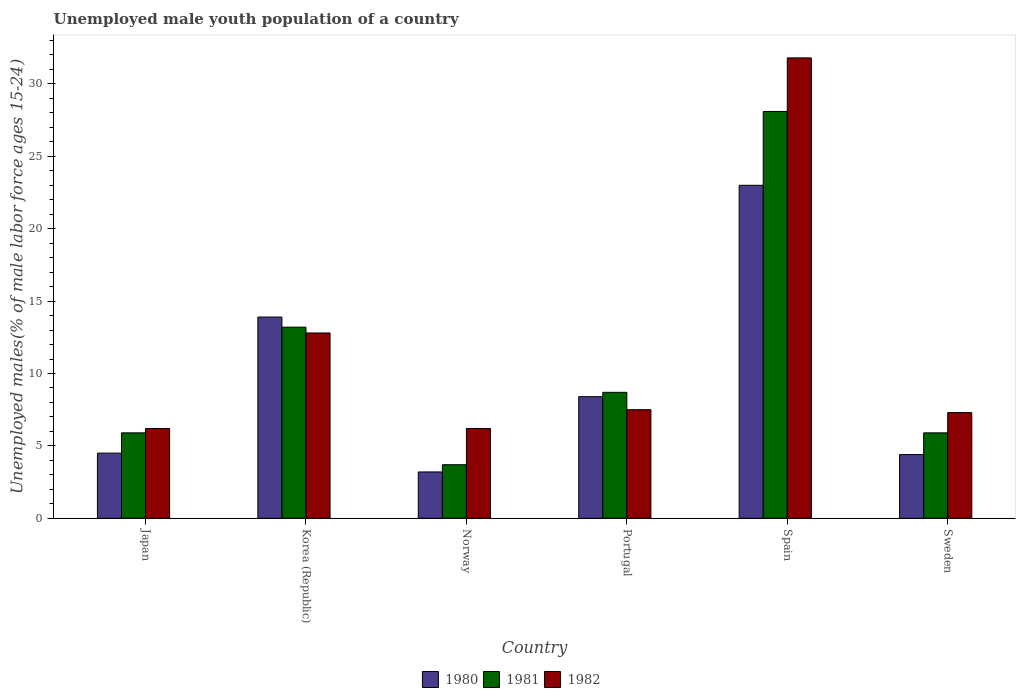How many different coloured bars are there?
Provide a short and direct response. 3. Are the number of bars per tick equal to the number of legend labels?
Offer a terse response. Yes. How many bars are there on the 4th tick from the left?
Your answer should be very brief. 3. What is the percentage of unemployed male youth population in 1981 in Portugal?
Keep it short and to the point. 8.7. Across all countries, what is the maximum percentage of unemployed male youth population in 1982?
Provide a short and direct response. 31.8. Across all countries, what is the minimum percentage of unemployed male youth population in 1980?
Your answer should be compact. 3.2. What is the total percentage of unemployed male youth population in 1981 in the graph?
Make the answer very short. 65.5. What is the difference between the percentage of unemployed male youth population in 1982 in Norway and that in Spain?
Give a very brief answer. -25.6. What is the difference between the percentage of unemployed male youth population in 1980 in Sweden and the percentage of unemployed male youth population in 1982 in Portugal?
Your answer should be compact. -3.1. What is the average percentage of unemployed male youth population in 1981 per country?
Provide a short and direct response. 10.92. What is the difference between the percentage of unemployed male youth population of/in 1981 and percentage of unemployed male youth population of/in 1980 in Sweden?
Make the answer very short. 1.5. In how many countries, is the percentage of unemployed male youth population in 1980 greater than 14 %?
Your response must be concise. 1. What is the ratio of the percentage of unemployed male youth population in 1980 in Japan to that in Korea (Republic)?
Your response must be concise. 0.32. Is the percentage of unemployed male youth population in 1981 in Norway less than that in Sweden?
Provide a short and direct response. Yes. What is the difference between the highest and the second highest percentage of unemployed male youth population in 1982?
Offer a terse response. 5.3. What is the difference between the highest and the lowest percentage of unemployed male youth population in 1982?
Provide a short and direct response. 25.6. Is the sum of the percentage of unemployed male youth population in 1982 in Japan and Spain greater than the maximum percentage of unemployed male youth population in 1980 across all countries?
Keep it short and to the point. Yes. What does the 2nd bar from the right in Portugal represents?
Provide a short and direct response. 1981. How many bars are there?
Give a very brief answer. 18. Are the values on the major ticks of Y-axis written in scientific E-notation?
Give a very brief answer. No. Does the graph contain any zero values?
Ensure brevity in your answer.  No. What is the title of the graph?
Provide a succinct answer. Unemployed male youth population of a country. Does "1960" appear as one of the legend labels in the graph?
Provide a short and direct response. No. What is the label or title of the Y-axis?
Keep it short and to the point. Unemployed males(% of male labor force ages 15-24). What is the Unemployed males(% of male labor force ages 15-24) of 1981 in Japan?
Your response must be concise. 5.9. What is the Unemployed males(% of male labor force ages 15-24) of 1982 in Japan?
Ensure brevity in your answer.  6.2. What is the Unemployed males(% of male labor force ages 15-24) of 1980 in Korea (Republic)?
Make the answer very short. 13.9. What is the Unemployed males(% of male labor force ages 15-24) of 1981 in Korea (Republic)?
Your answer should be very brief. 13.2. What is the Unemployed males(% of male labor force ages 15-24) of 1982 in Korea (Republic)?
Provide a short and direct response. 12.8. What is the Unemployed males(% of male labor force ages 15-24) of 1980 in Norway?
Provide a succinct answer. 3.2. What is the Unemployed males(% of male labor force ages 15-24) in 1981 in Norway?
Provide a short and direct response. 3.7. What is the Unemployed males(% of male labor force ages 15-24) in 1982 in Norway?
Offer a terse response. 6.2. What is the Unemployed males(% of male labor force ages 15-24) in 1980 in Portugal?
Provide a short and direct response. 8.4. What is the Unemployed males(% of male labor force ages 15-24) in 1981 in Portugal?
Your answer should be very brief. 8.7. What is the Unemployed males(% of male labor force ages 15-24) in 1982 in Portugal?
Your response must be concise. 7.5. What is the Unemployed males(% of male labor force ages 15-24) in 1980 in Spain?
Make the answer very short. 23. What is the Unemployed males(% of male labor force ages 15-24) in 1981 in Spain?
Your response must be concise. 28.1. What is the Unemployed males(% of male labor force ages 15-24) in 1982 in Spain?
Make the answer very short. 31.8. What is the Unemployed males(% of male labor force ages 15-24) in 1980 in Sweden?
Provide a succinct answer. 4.4. What is the Unemployed males(% of male labor force ages 15-24) of 1981 in Sweden?
Offer a very short reply. 5.9. What is the Unemployed males(% of male labor force ages 15-24) in 1982 in Sweden?
Ensure brevity in your answer.  7.3. Across all countries, what is the maximum Unemployed males(% of male labor force ages 15-24) in 1981?
Offer a terse response. 28.1. Across all countries, what is the maximum Unemployed males(% of male labor force ages 15-24) in 1982?
Make the answer very short. 31.8. Across all countries, what is the minimum Unemployed males(% of male labor force ages 15-24) of 1980?
Offer a terse response. 3.2. Across all countries, what is the minimum Unemployed males(% of male labor force ages 15-24) in 1981?
Make the answer very short. 3.7. Across all countries, what is the minimum Unemployed males(% of male labor force ages 15-24) in 1982?
Your response must be concise. 6.2. What is the total Unemployed males(% of male labor force ages 15-24) of 1980 in the graph?
Offer a very short reply. 57.4. What is the total Unemployed males(% of male labor force ages 15-24) of 1981 in the graph?
Keep it short and to the point. 65.5. What is the total Unemployed males(% of male labor force ages 15-24) in 1982 in the graph?
Your answer should be compact. 71.8. What is the difference between the Unemployed males(% of male labor force ages 15-24) of 1980 in Japan and that in Norway?
Your answer should be compact. 1.3. What is the difference between the Unemployed males(% of male labor force ages 15-24) of 1982 in Japan and that in Norway?
Ensure brevity in your answer.  0. What is the difference between the Unemployed males(% of male labor force ages 15-24) in 1980 in Japan and that in Portugal?
Ensure brevity in your answer.  -3.9. What is the difference between the Unemployed males(% of male labor force ages 15-24) in 1982 in Japan and that in Portugal?
Your response must be concise. -1.3. What is the difference between the Unemployed males(% of male labor force ages 15-24) in 1980 in Japan and that in Spain?
Make the answer very short. -18.5. What is the difference between the Unemployed males(% of male labor force ages 15-24) in 1981 in Japan and that in Spain?
Provide a succinct answer. -22.2. What is the difference between the Unemployed males(% of male labor force ages 15-24) in 1982 in Japan and that in Spain?
Offer a very short reply. -25.6. What is the difference between the Unemployed males(% of male labor force ages 15-24) of 1981 in Japan and that in Sweden?
Give a very brief answer. 0. What is the difference between the Unemployed males(% of male labor force ages 15-24) of 1982 in Japan and that in Sweden?
Your response must be concise. -1.1. What is the difference between the Unemployed males(% of male labor force ages 15-24) in 1981 in Korea (Republic) and that in Norway?
Offer a very short reply. 9.5. What is the difference between the Unemployed males(% of male labor force ages 15-24) in 1982 in Korea (Republic) and that in Norway?
Your answer should be very brief. 6.6. What is the difference between the Unemployed males(% of male labor force ages 15-24) of 1980 in Korea (Republic) and that in Portugal?
Provide a short and direct response. 5.5. What is the difference between the Unemployed males(% of male labor force ages 15-24) of 1982 in Korea (Republic) and that in Portugal?
Keep it short and to the point. 5.3. What is the difference between the Unemployed males(% of male labor force ages 15-24) in 1980 in Korea (Republic) and that in Spain?
Provide a short and direct response. -9.1. What is the difference between the Unemployed males(% of male labor force ages 15-24) in 1981 in Korea (Republic) and that in Spain?
Provide a short and direct response. -14.9. What is the difference between the Unemployed males(% of male labor force ages 15-24) in 1982 in Korea (Republic) and that in Spain?
Offer a terse response. -19. What is the difference between the Unemployed males(% of male labor force ages 15-24) in 1981 in Korea (Republic) and that in Sweden?
Give a very brief answer. 7.3. What is the difference between the Unemployed males(% of male labor force ages 15-24) of 1980 in Norway and that in Portugal?
Give a very brief answer. -5.2. What is the difference between the Unemployed males(% of male labor force ages 15-24) of 1982 in Norway and that in Portugal?
Provide a short and direct response. -1.3. What is the difference between the Unemployed males(% of male labor force ages 15-24) of 1980 in Norway and that in Spain?
Ensure brevity in your answer.  -19.8. What is the difference between the Unemployed males(% of male labor force ages 15-24) in 1981 in Norway and that in Spain?
Provide a succinct answer. -24.4. What is the difference between the Unemployed males(% of male labor force ages 15-24) of 1982 in Norway and that in Spain?
Your response must be concise. -25.6. What is the difference between the Unemployed males(% of male labor force ages 15-24) in 1980 in Norway and that in Sweden?
Keep it short and to the point. -1.2. What is the difference between the Unemployed males(% of male labor force ages 15-24) of 1982 in Norway and that in Sweden?
Ensure brevity in your answer.  -1.1. What is the difference between the Unemployed males(% of male labor force ages 15-24) in 1980 in Portugal and that in Spain?
Your answer should be very brief. -14.6. What is the difference between the Unemployed males(% of male labor force ages 15-24) of 1981 in Portugal and that in Spain?
Make the answer very short. -19.4. What is the difference between the Unemployed males(% of male labor force ages 15-24) of 1982 in Portugal and that in Spain?
Your answer should be very brief. -24.3. What is the difference between the Unemployed males(% of male labor force ages 15-24) of 1981 in Portugal and that in Sweden?
Your response must be concise. 2.8. What is the difference between the Unemployed males(% of male labor force ages 15-24) of 1982 in Portugal and that in Sweden?
Ensure brevity in your answer.  0.2. What is the difference between the Unemployed males(% of male labor force ages 15-24) of 1981 in Spain and that in Sweden?
Your answer should be very brief. 22.2. What is the difference between the Unemployed males(% of male labor force ages 15-24) of 1980 in Japan and the Unemployed males(% of male labor force ages 15-24) of 1981 in Korea (Republic)?
Provide a succinct answer. -8.7. What is the difference between the Unemployed males(% of male labor force ages 15-24) in 1980 in Japan and the Unemployed males(% of male labor force ages 15-24) in 1982 in Korea (Republic)?
Provide a succinct answer. -8.3. What is the difference between the Unemployed males(% of male labor force ages 15-24) of 1981 in Japan and the Unemployed males(% of male labor force ages 15-24) of 1982 in Korea (Republic)?
Make the answer very short. -6.9. What is the difference between the Unemployed males(% of male labor force ages 15-24) in 1980 in Japan and the Unemployed males(% of male labor force ages 15-24) in 1982 in Norway?
Your answer should be compact. -1.7. What is the difference between the Unemployed males(% of male labor force ages 15-24) of 1980 in Japan and the Unemployed males(% of male labor force ages 15-24) of 1981 in Portugal?
Offer a terse response. -4.2. What is the difference between the Unemployed males(% of male labor force ages 15-24) in 1980 in Japan and the Unemployed males(% of male labor force ages 15-24) in 1982 in Portugal?
Offer a terse response. -3. What is the difference between the Unemployed males(% of male labor force ages 15-24) of 1980 in Japan and the Unemployed males(% of male labor force ages 15-24) of 1981 in Spain?
Your answer should be very brief. -23.6. What is the difference between the Unemployed males(% of male labor force ages 15-24) of 1980 in Japan and the Unemployed males(% of male labor force ages 15-24) of 1982 in Spain?
Make the answer very short. -27.3. What is the difference between the Unemployed males(% of male labor force ages 15-24) in 1981 in Japan and the Unemployed males(% of male labor force ages 15-24) in 1982 in Spain?
Offer a terse response. -25.9. What is the difference between the Unemployed males(% of male labor force ages 15-24) of 1980 in Japan and the Unemployed males(% of male labor force ages 15-24) of 1982 in Sweden?
Offer a very short reply. -2.8. What is the difference between the Unemployed males(% of male labor force ages 15-24) in 1980 in Korea (Republic) and the Unemployed males(% of male labor force ages 15-24) in 1981 in Norway?
Offer a terse response. 10.2. What is the difference between the Unemployed males(% of male labor force ages 15-24) in 1980 in Korea (Republic) and the Unemployed males(% of male labor force ages 15-24) in 1982 in Norway?
Give a very brief answer. 7.7. What is the difference between the Unemployed males(% of male labor force ages 15-24) in 1981 in Korea (Republic) and the Unemployed males(% of male labor force ages 15-24) in 1982 in Norway?
Offer a terse response. 7. What is the difference between the Unemployed males(% of male labor force ages 15-24) in 1980 in Korea (Republic) and the Unemployed males(% of male labor force ages 15-24) in 1982 in Portugal?
Keep it short and to the point. 6.4. What is the difference between the Unemployed males(% of male labor force ages 15-24) of 1981 in Korea (Republic) and the Unemployed males(% of male labor force ages 15-24) of 1982 in Portugal?
Offer a very short reply. 5.7. What is the difference between the Unemployed males(% of male labor force ages 15-24) of 1980 in Korea (Republic) and the Unemployed males(% of male labor force ages 15-24) of 1981 in Spain?
Keep it short and to the point. -14.2. What is the difference between the Unemployed males(% of male labor force ages 15-24) of 1980 in Korea (Republic) and the Unemployed males(% of male labor force ages 15-24) of 1982 in Spain?
Provide a succinct answer. -17.9. What is the difference between the Unemployed males(% of male labor force ages 15-24) in 1981 in Korea (Republic) and the Unemployed males(% of male labor force ages 15-24) in 1982 in Spain?
Provide a short and direct response. -18.6. What is the difference between the Unemployed males(% of male labor force ages 15-24) in 1980 in Korea (Republic) and the Unemployed males(% of male labor force ages 15-24) in 1981 in Sweden?
Make the answer very short. 8. What is the difference between the Unemployed males(% of male labor force ages 15-24) in 1981 in Korea (Republic) and the Unemployed males(% of male labor force ages 15-24) in 1982 in Sweden?
Make the answer very short. 5.9. What is the difference between the Unemployed males(% of male labor force ages 15-24) in 1980 in Norway and the Unemployed males(% of male labor force ages 15-24) in 1981 in Spain?
Provide a short and direct response. -24.9. What is the difference between the Unemployed males(% of male labor force ages 15-24) in 1980 in Norway and the Unemployed males(% of male labor force ages 15-24) in 1982 in Spain?
Provide a short and direct response. -28.6. What is the difference between the Unemployed males(% of male labor force ages 15-24) in 1981 in Norway and the Unemployed males(% of male labor force ages 15-24) in 1982 in Spain?
Ensure brevity in your answer.  -28.1. What is the difference between the Unemployed males(% of male labor force ages 15-24) in 1980 in Portugal and the Unemployed males(% of male labor force ages 15-24) in 1981 in Spain?
Provide a short and direct response. -19.7. What is the difference between the Unemployed males(% of male labor force ages 15-24) in 1980 in Portugal and the Unemployed males(% of male labor force ages 15-24) in 1982 in Spain?
Give a very brief answer. -23.4. What is the difference between the Unemployed males(% of male labor force ages 15-24) in 1981 in Portugal and the Unemployed males(% of male labor force ages 15-24) in 1982 in Spain?
Give a very brief answer. -23.1. What is the difference between the Unemployed males(% of male labor force ages 15-24) of 1980 in Portugal and the Unemployed males(% of male labor force ages 15-24) of 1981 in Sweden?
Your response must be concise. 2.5. What is the difference between the Unemployed males(% of male labor force ages 15-24) of 1980 in Spain and the Unemployed males(% of male labor force ages 15-24) of 1982 in Sweden?
Give a very brief answer. 15.7. What is the difference between the Unemployed males(% of male labor force ages 15-24) in 1981 in Spain and the Unemployed males(% of male labor force ages 15-24) in 1982 in Sweden?
Your response must be concise. 20.8. What is the average Unemployed males(% of male labor force ages 15-24) of 1980 per country?
Your answer should be compact. 9.57. What is the average Unemployed males(% of male labor force ages 15-24) in 1981 per country?
Give a very brief answer. 10.92. What is the average Unemployed males(% of male labor force ages 15-24) in 1982 per country?
Your response must be concise. 11.97. What is the difference between the Unemployed males(% of male labor force ages 15-24) of 1980 and Unemployed males(% of male labor force ages 15-24) of 1982 in Japan?
Your answer should be compact. -1.7. What is the difference between the Unemployed males(% of male labor force ages 15-24) of 1980 and Unemployed males(% of male labor force ages 15-24) of 1981 in Norway?
Your answer should be compact. -0.5. What is the difference between the Unemployed males(% of male labor force ages 15-24) of 1980 and Unemployed males(% of male labor force ages 15-24) of 1982 in Norway?
Provide a succinct answer. -3. What is the difference between the Unemployed males(% of male labor force ages 15-24) of 1981 and Unemployed males(% of male labor force ages 15-24) of 1982 in Norway?
Provide a short and direct response. -2.5. What is the difference between the Unemployed males(% of male labor force ages 15-24) of 1981 and Unemployed males(% of male labor force ages 15-24) of 1982 in Portugal?
Make the answer very short. 1.2. What is the difference between the Unemployed males(% of male labor force ages 15-24) in 1981 and Unemployed males(% of male labor force ages 15-24) in 1982 in Spain?
Ensure brevity in your answer.  -3.7. What is the difference between the Unemployed males(% of male labor force ages 15-24) of 1980 and Unemployed males(% of male labor force ages 15-24) of 1981 in Sweden?
Offer a terse response. -1.5. What is the difference between the Unemployed males(% of male labor force ages 15-24) in 1980 and Unemployed males(% of male labor force ages 15-24) in 1982 in Sweden?
Your response must be concise. -2.9. What is the ratio of the Unemployed males(% of male labor force ages 15-24) in 1980 in Japan to that in Korea (Republic)?
Your response must be concise. 0.32. What is the ratio of the Unemployed males(% of male labor force ages 15-24) of 1981 in Japan to that in Korea (Republic)?
Offer a terse response. 0.45. What is the ratio of the Unemployed males(% of male labor force ages 15-24) of 1982 in Japan to that in Korea (Republic)?
Offer a very short reply. 0.48. What is the ratio of the Unemployed males(% of male labor force ages 15-24) of 1980 in Japan to that in Norway?
Your answer should be very brief. 1.41. What is the ratio of the Unemployed males(% of male labor force ages 15-24) in 1981 in Japan to that in Norway?
Give a very brief answer. 1.59. What is the ratio of the Unemployed males(% of male labor force ages 15-24) in 1980 in Japan to that in Portugal?
Provide a succinct answer. 0.54. What is the ratio of the Unemployed males(% of male labor force ages 15-24) of 1981 in Japan to that in Portugal?
Offer a very short reply. 0.68. What is the ratio of the Unemployed males(% of male labor force ages 15-24) of 1982 in Japan to that in Portugal?
Offer a very short reply. 0.83. What is the ratio of the Unemployed males(% of male labor force ages 15-24) of 1980 in Japan to that in Spain?
Provide a succinct answer. 0.2. What is the ratio of the Unemployed males(% of male labor force ages 15-24) in 1981 in Japan to that in Spain?
Offer a terse response. 0.21. What is the ratio of the Unemployed males(% of male labor force ages 15-24) in 1982 in Japan to that in Spain?
Your answer should be compact. 0.2. What is the ratio of the Unemployed males(% of male labor force ages 15-24) in 1980 in Japan to that in Sweden?
Provide a short and direct response. 1.02. What is the ratio of the Unemployed males(% of male labor force ages 15-24) of 1981 in Japan to that in Sweden?
Ensure brevity in your answer.  1. What is the ratio of the Unemployed males(% of male labor force ages 15-24) of 1982 in Japan to that in Sweden?
Provide a succinct answer. 0.85. What is the ratio of the Unemployed males(% of male labor force ages 15-24) of 1980 in Korea (Republic) to that in Norway?
Make the answer very short. 4.34. What is the ratio of the Unemployed males(% of male labor force ages 15-24) in 1981 in Korea (Republic) to that in Norway?
Provide a succinct answer. 3.57. What is the ratio of the Unemployed males(% of male labor force ages 15-24) of 1982 in Korea (Republic) to that in Norway?
Keep it short and to the point. 2.06. What is the ratio of the Unemployed males(% of male labor force ages 15-24) of 1980 in Korea (Republic) to that in Portugal?
Offer a terse response. 1.65. What is the ratio of the Unemployed males(% of male labor force ages 15-24) of 1981 in Korea (Republic) to that in Portugal?
Offer a very short reply. 1.52. What is the ratio of the Unemployed males(% of male labor force ages 15-24) of 1982 in Korea (Republic) to that in Portugal?
Your response must be concise. 1.71. What is the ratio of the Unemployed males(% of male labor force ages 15-24) of 1980 in Korea (Republic) to that in Spain?
Your answer should be compact. 0.6. What is the ratio of the Unemployed males(% of male labor force ages 15-24) in 1981 in Korea (Republic) to that in Spain?
Offer a very short reply. 0.47. What is the ratio of the Unemployed males(% of male labor force ages 15-24) of 1982 in Korea (Republic) to that in Spain?
Ensure brevity in your answer.  0.4. What is the ratio of the Unemployed males(% of male labor force ages 15-24) of 1980 in Korea (Republic) to that in Sweden?
Your answer should be very brief. 3.16. What is the ratio of the Unemployed males(% of male labor force ages 15-24) in 1981 in Korea (Republic) to that in Sweden?
Your answer should be very brief. 2.24. What is the ratio of the Unemployed males(% of male labor force ages 15-24) in 1982 in Korea (Republic) to that in Sweden?
Ensure brevity in your answer.  1.75. What is the ratio of the Unemployed males(% of male labor force ages 15-24) of 1980 in Norway to that in Portugal?
Your response must be concise. 0.38. What is the ratio of the Unemployed males(% of male labor force ages 15-24) in 1981 in Norway to that in Portugal?
Offer a terse response. 0.43. What is the ratio of the Unemployed males(% of male labor force ages 15-24) in 1982 in Norway to that in Portugal?
Provide a short and direct response. 0.83. What is the ratio of the Unemployed males(% of male labor force ages 15-24) in 1980 in Norway to that in Spain?
Keep it short and to the point. 0.14. What is the ratio of the Unemployed males(% of male labor force ages 15-24) in 1981 in Norway to that in Spain?
Give a very brief answer. 0.13. What is the ratio of the Unemployed males(% of male labor force ages 15-24) of 1982 in Norway to that in Spain?
Your response must be concise. 0.2. What is the ratio of the Unemployed males(% of male labor force ages 15-24) in 1980 in Norway to that in Sweden?
Make the answer very short. 0.73. What is the ratio of the Unemployed males(% of male labor force ages 15-24) of 1981 in Norway to that in Sweden?
Your answer should be compact. 0.63. What is the ratio of the Unemployed males(% of male labor force ages 15-24) of 1982 in Norway to that in Sweden?
Offer a terse response. 0.85. What is the ratio of the Unemployed males(% of male labor force ages 15-24) in 1980 in Portugal to that in Spain?
Give a very brief answer. 0.37. What is the ratio of the Unemployed males(% of male labor force ages 15-24) of 1981 in Portugal to that in Spain?
Give a very brief answer. 0.31. What is the ratio of the Unemployed males(% of male labor force ages 15-24) of 1982 in Portugal to that in Spain?
Provide a succinct answer. 0.24. What is the ratio of the Unemployed males(% of male labor force ages 15-24) of 1980 in Portugal to that in Sweden?
Your answer should be compact. 1.91. What is the ratio of the Unemployed males(% of male labor force ages 15-24) of 1981 in Portugal to that in Sweden?
Your answer should be compact. 1.47. What is the ratio of the Unemployed males(% of male labor force ages 15-24) of 1982 in Portugal to that in Sweden?
Ensure brevity in your answer.  1.03. What is the ratio of the Unemployed males(% of male labor force ages 15-24) of 1980 in Spain to that in Sweden?
Provide a succinct answer. 5.23. What is the ratio of the Unemployed males(% of male labor force ages 15-24) in 1981 in Spain to that in Sweden?
Provide a short and direct response. 4.76. What is the ratio of the Unemployed males(% of male labor force ages 15-24) of 1982 in Spain to that in Sweden?
Make the answer very short. 4.36. What is the difference between the highest and the lowest Unemployed males(% of male labor force ages 15-24) of 1980?
Keep it short and to the point. 19.8. What is the difference between the highest and the lowest Unemployed males(% of male labor force ages 15-24) in 1981?
Your answer should be compact. 24.4. What is the difference between the highest and the lowest Unemployed males(% of male labor force ages 15-24) in 1982?
Give a very brief answer. 25.6. 